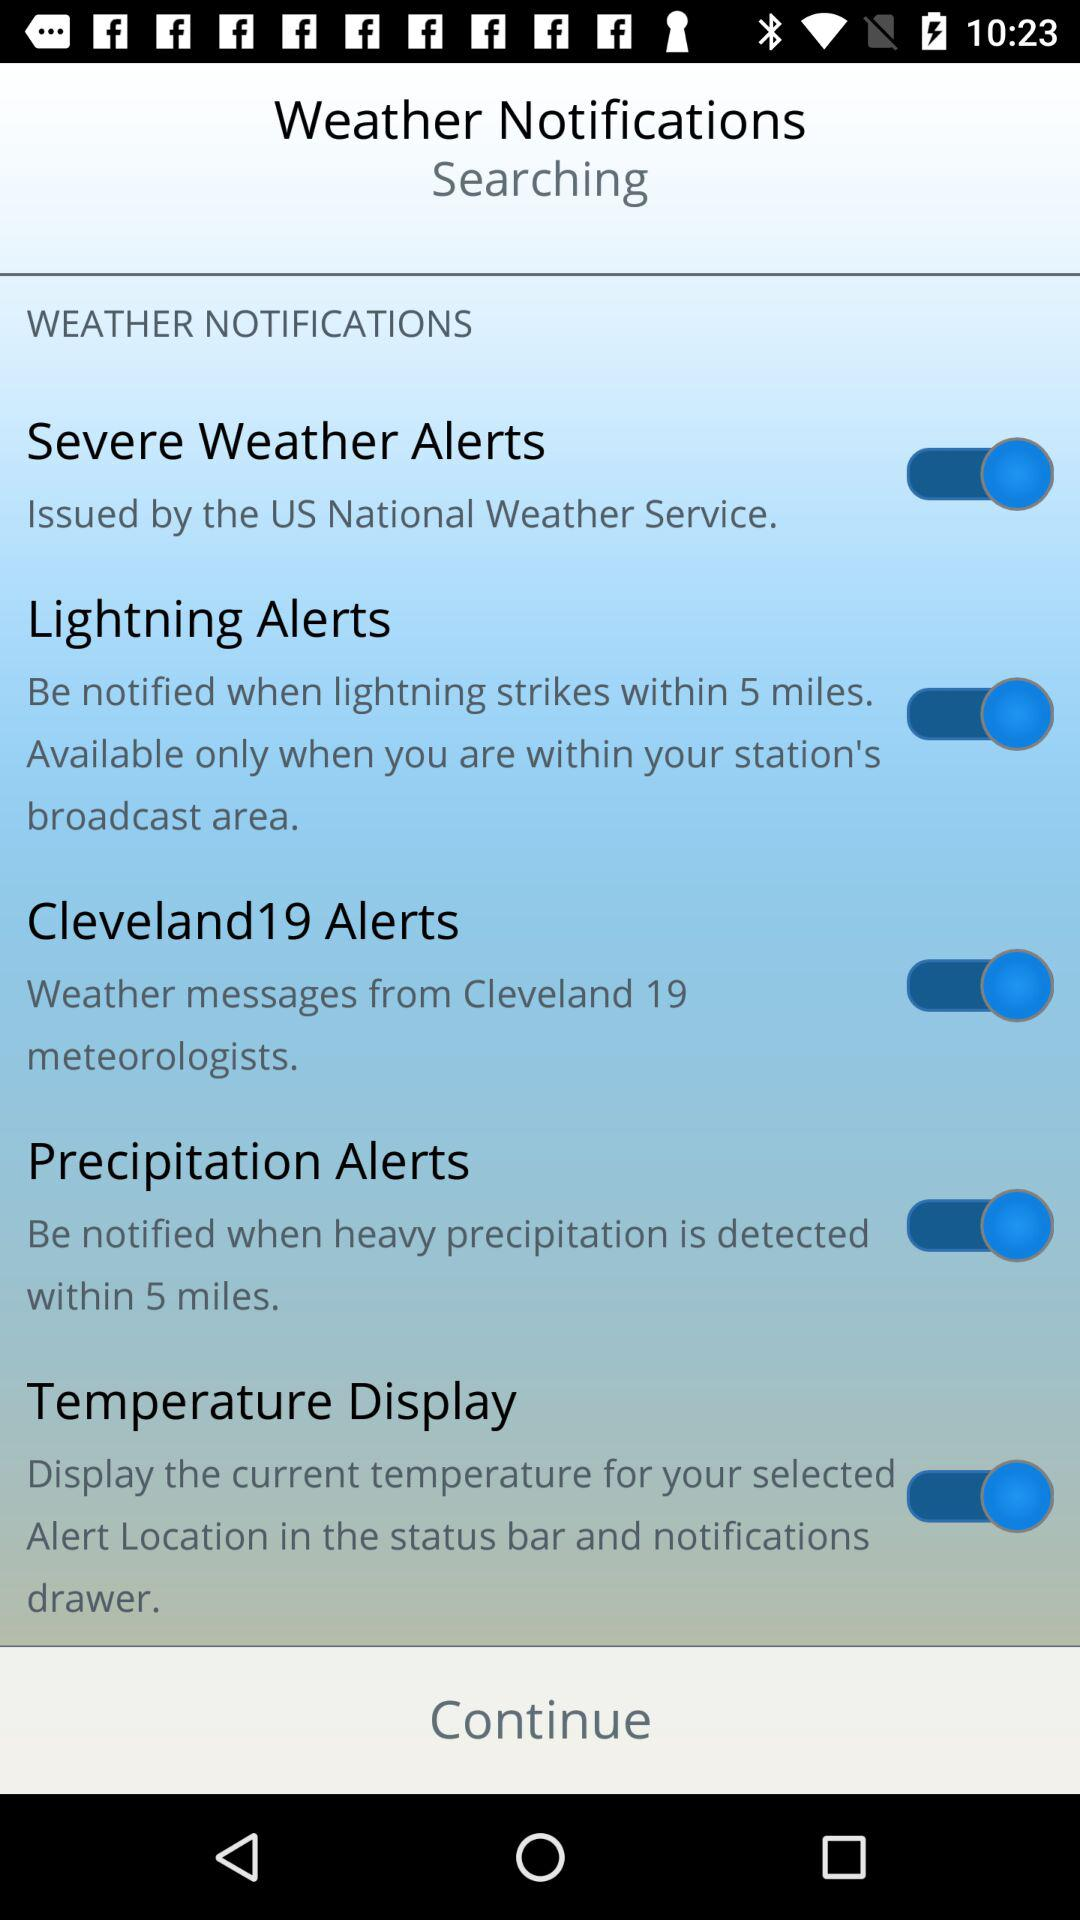What is the status of the "Severe Weather Alerts"? The status of the "Severe Weather Alerts" is "on". 